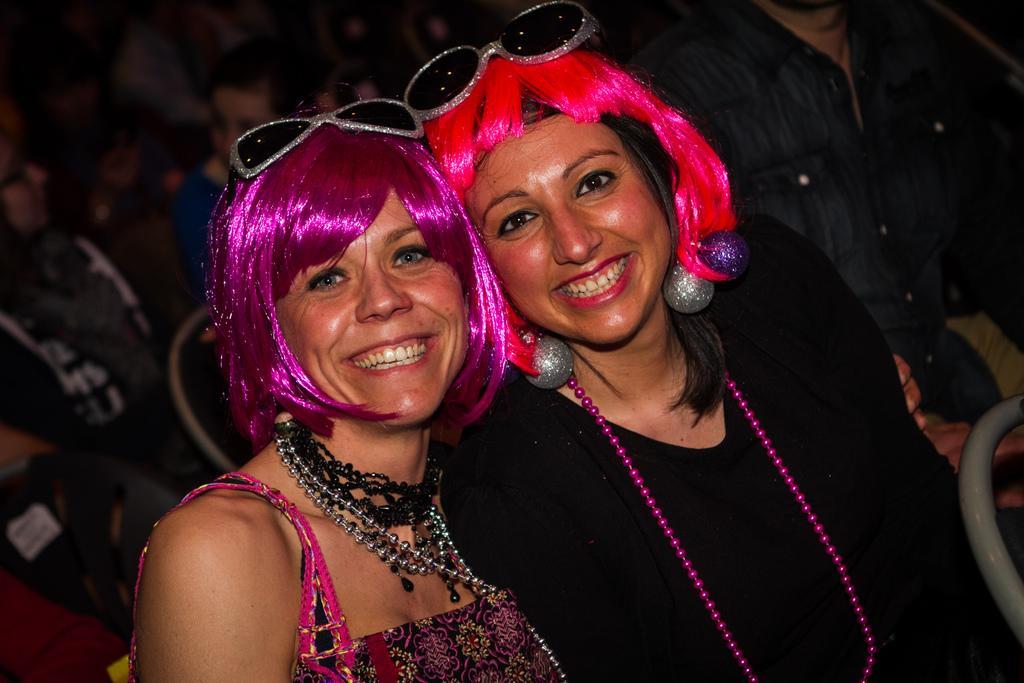Please provide a concise description of this image. In this picture we can see there are two women in the wigs and the women are smiling. Behind the people there is a blurred background. 